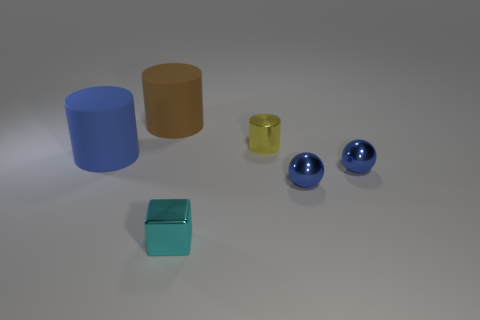Add 1 big brown metal spheres. How many objects exist? 7 Subtract all spheres. How many objects are left? 4 Add 2 big brown shiny things. How many big brown shiny things exist? 2 Subtract 1 cyan blocks. How many objects are left? 5 Subtract all matte cylinders. Subtract all large brown matte cylinders. How many objects are left? 3 Add 2 tiny blue metallic balls. How many tiny blue metallic balls are left? 4 